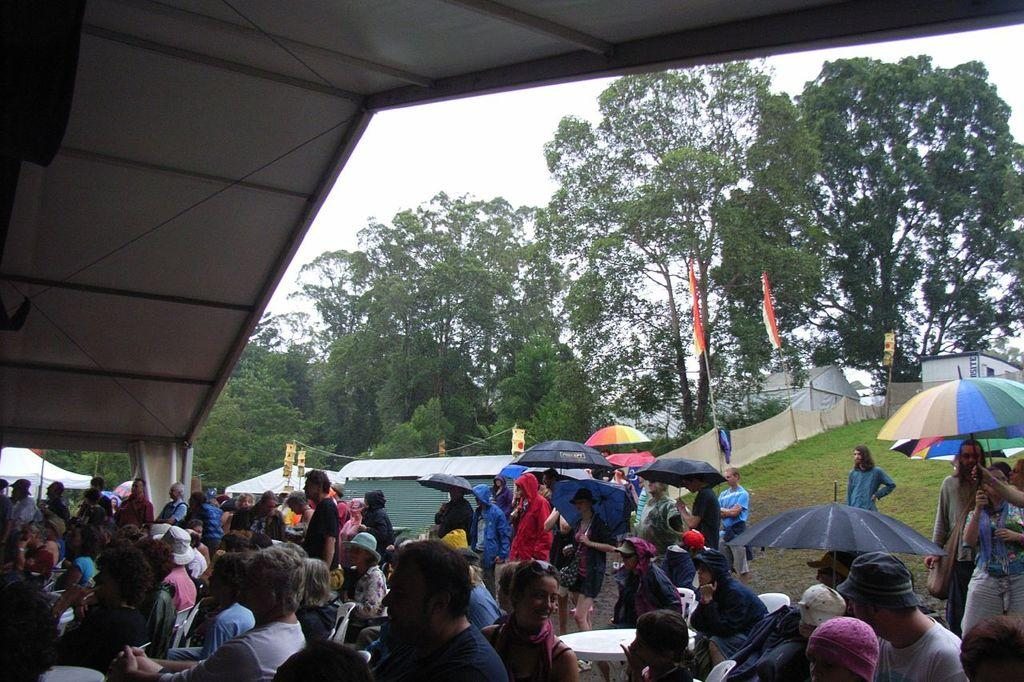How many people are in the group visible in the image? There is a group of people in the image, but the exact number cannot be determined from the provided facts. What are some people in the group using to protect themselves from the elements? Some people in the group are holding umbrellas. What type of temporary shelters can be seen in the image? There are tents in the image. What other objects can be seen in the image besides the people and tents? There are flags and chairs in the image. What can be seen in the background of the image? There are trees and the sky visible in the background of the image. Can you tell me how many stars are visible in the image? There is no mention of stars in the provided facts, so it cannot be determined if any are visible in the image. What type of family gathering is taking place in the image? The provided facts do not mention a family gathering or any specific event, so it cannot be determined what type of gathering is taking place. 